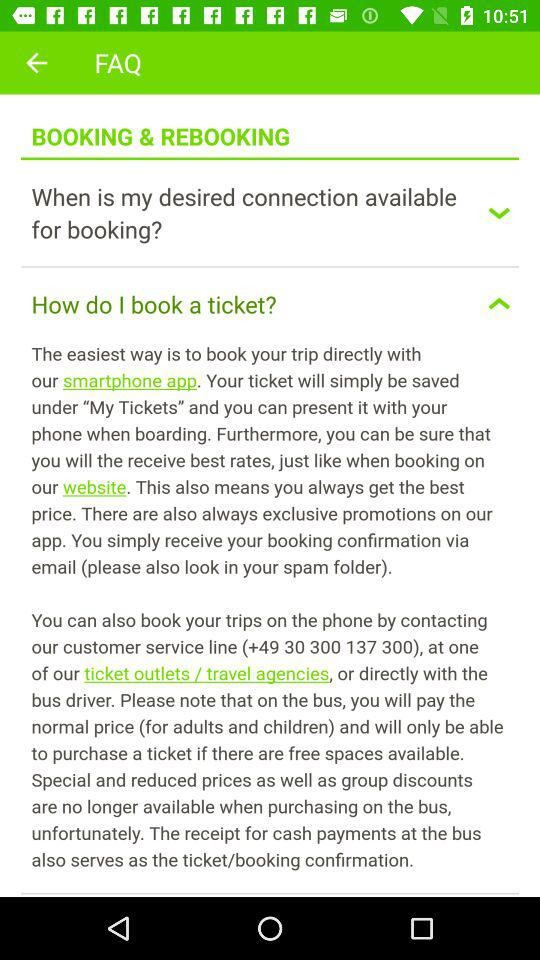What's the customer care number? The customer care number is +49 30 300 137 300. 